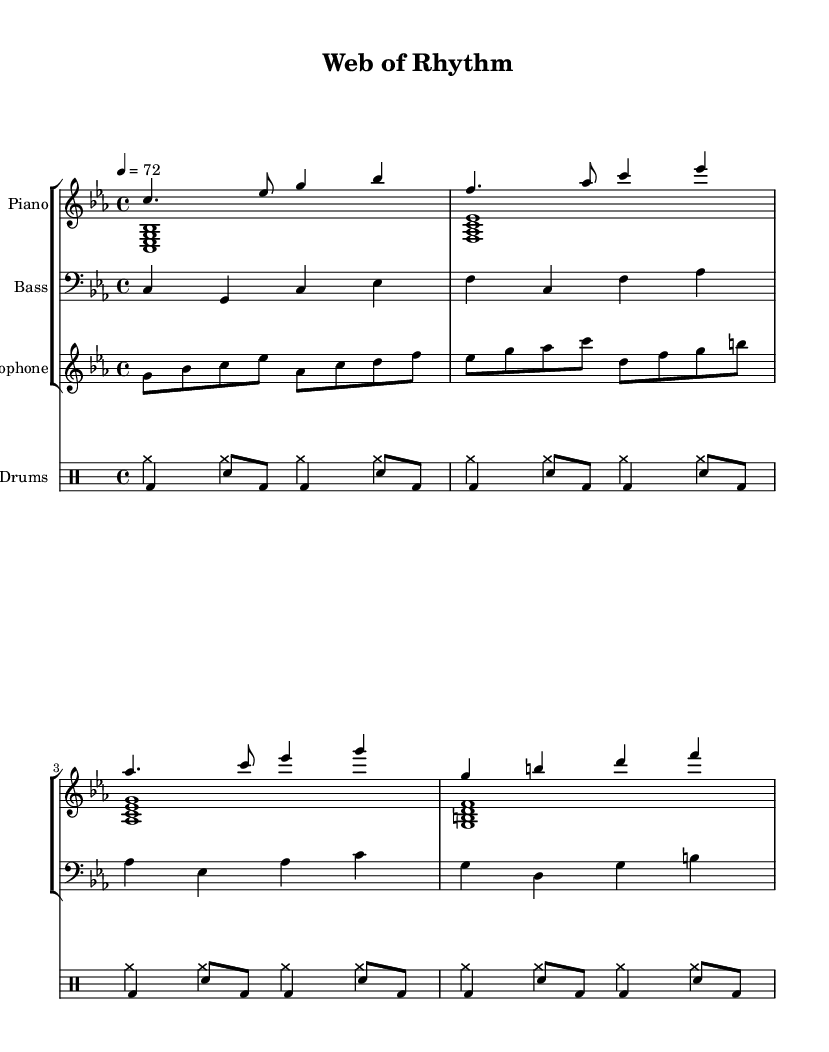What is the key signature of this music? The key signature is C minor, which contains three flats: B flat, E flat, and A flat. This is indicated by the placement of three flat symbols at the beginning of the staff.
Answer: C minor What is the time signature of this music? The time signature is 4/4, which means there are four beats in each measure and the quarter note gets one beat. This is shown at the beginning of the score with the "4/4" notation.
Answer: 4/4 What is the tempo marking of this piece? The tempo marking is "quarter note = 72," which indicates the speed at which the piece should be played. This is found at the beginning of the score under the tempo indication.
Answer: 72 How many measures are in the piano part? By counting the measures in the piano staff, there are eight measures total in the right-hand and left-hand voices combined. Each bar line represents the end of a measure.
Answer: 8 What instruments are featured in this composition? The composition features piano, bass, saxophone, and drums. Each instrument is listed at the start of its respective staff, making it clear what instruments are included.
Answer: Piano, Bass, Saxophone, Drums Which instrument plays the melody in this piece? The saxophone plays the melody, as indicated by its part being written above the other instruments and featuring the most varied melodic line.
Answer: Saxophone What style influences does this music exhibit? The music exhibits influences of smooth jazz fusion, characterized by its relaxed tempo and blending of various genres and improvisational elements. This is evident in the sophisticated harmonic progressions and rhythmic patterns.
Answer: Smooth jazz fusion 